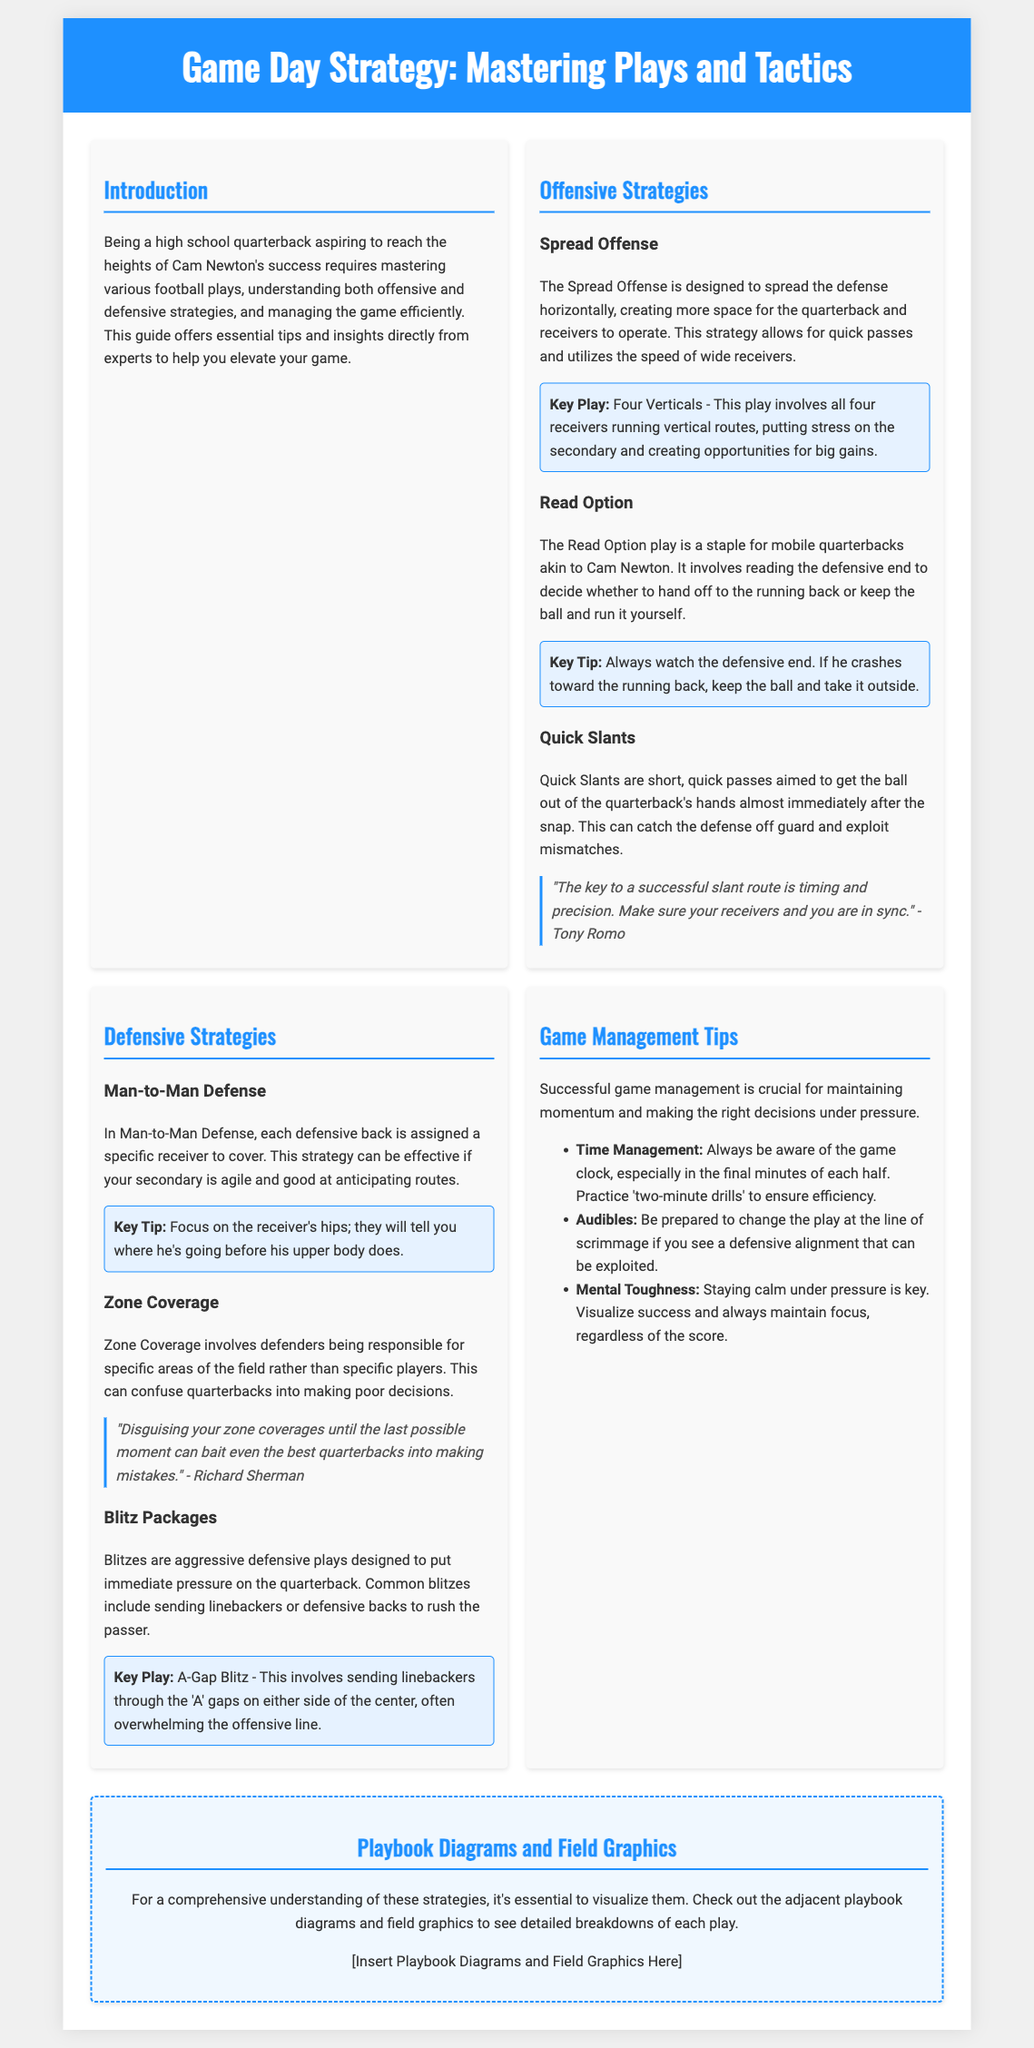What is the title of the magazine? The title of the magazine is presented prominently at the top of the document.
Answer: Game Day Strategy: Mastering Plays and Tactics Who wrote the expert quote about slant routes? The expert quote about slant routes is attributed to a well-known former NFL player.
Answer: Tony Romo What is the key play in the Spread Offense? The document identifies a specific offensive play as essential to the Spread Offense strategy.
Answer: Four Verticals What type of defense involves specific areas of responsibility? The document details a defensive strategy that assigns players to zones rather than specific opponents.
Answer: Zone Coverage What is a significant factor in successful game management? The document emphasizes the importance of maintaining composure and control during high-pressure situations.
Answer: Mental Toughness Which strategy is best for mobile quarterbacks? The document highlights a particular offensive play style that suits agile quarterbacks.
Answer: Read Option What is a key tip for Man-to-Man Defense? The document provides a critical tip for effectively executing this defensive strategy.
Answer: Focus on the receiver's hips What does the playbook section intend to provide? The section discusses a visual tool that aids in understanding the strategies covered in the magazine.
Answer: Diagrams and graphics What should you practice for time management? The document suggests a specific type of drill to help manage time effectively during games.
Answer: Two-minute drills 